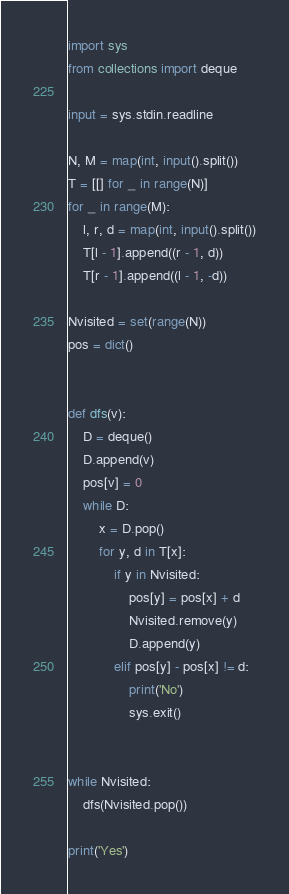<code> <loc_0><loc_0><loc_500><loc_500><_Python_>import sys
from collections import deque

input = sys.stdin.readline

N, M = map(int, input().split())
T = [[] for _ in range(N)]
for _ in range(M):
    l, r, d = map(int, input().split())
    T[l - 1].append((r - 1, d))
    T[r - 1].append((l - 1, -d))

Nvisited = set(range(N))
pos = dict()


def dfs(v):
    D = deque()
    D.append(v)
    pos[v] = 0
    while D:
        x = D.pop()
        for y, d in T[x]:
            if y in Nvisited:
                pos[y] = pos[x] + d
                Nvisited.remove(y)
                D.append(y)
            elif pos[y] - pos[x] != d:
                print('No')
                sys.exit()


while Nvisited:
    dfs(Nvisited.pop())

print('Yes')
</code> 